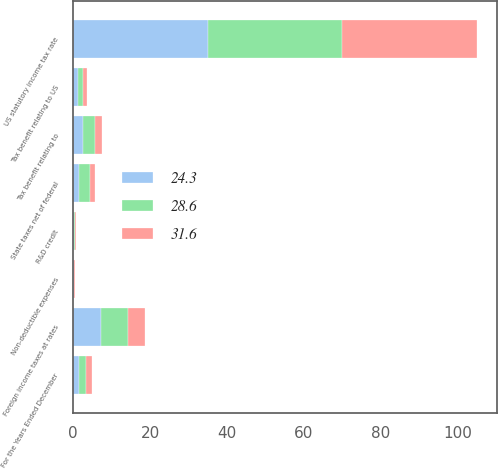<chart> <loc_0><loc_0><loc_500><loc_500><stacked_bar_chart><ecel><fcel>For the Years Ended December<fcel>US statutory income tax rate<fcel>State taxes net of federal<fcel>Foreign income taxes at rates<fcel>Tax benefit relating to<fcel>Tax benefit relating to US<fcel>R&D credit<fcel>Non-deductible expenses<nl><fcel>24.3<fcel>1.6<fcel>35<fcel>1.6<fcel>7.3<fcel>2.5<fcel>1.3<fcel>0.1<fcel>0.1<nl><fcel>28.6<fcel>1.6<fcel>35<fcel>2.7<fcel>7<fcel>3.1<fcel>1.2<fcel>0.4<fcel>0.2<nl><fcel>31.6<fcel>1.6<fcel>35<fcel>1.3<fcel>4.3<fcel>2<fcel>1.2<fcel>0.1<fcel>0.1<nl></chart> 